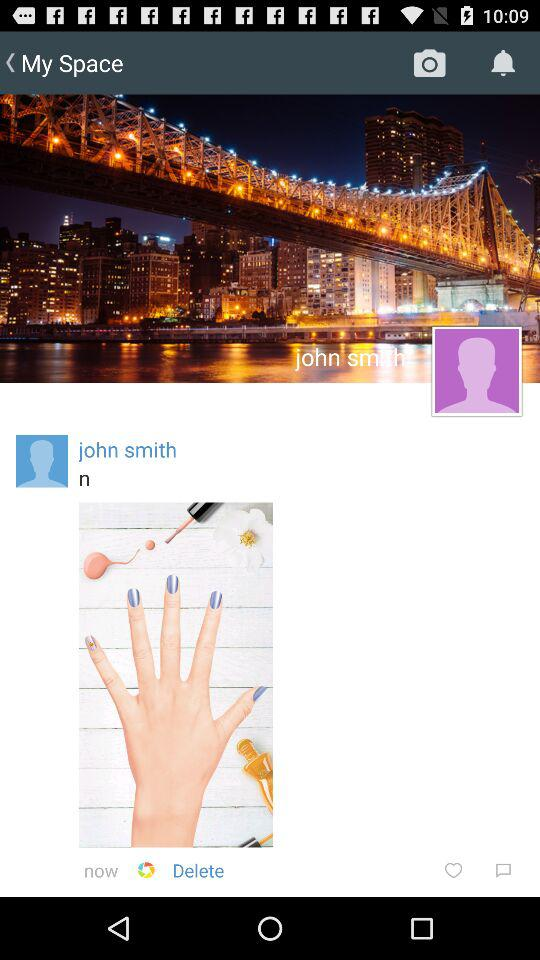What is the user name? The user name is John Smith. 